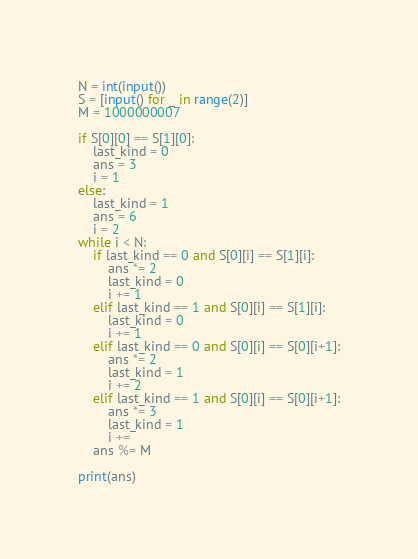Convert code to text. <code><loc_0><loc_0><loc_500><loc_500><_Python_>N = int(input())
S = [input() for _ in range(2)]
M = 1000000007

if S[0][0] == S[1][0]:
    last_kind = 0
    ans = 3
    i = 1
else:
    last_kind = 1
    ans = 6
    i = 2
while i < N:
    if last_kind == 0 and S[0][i] == S[1][i]:
        ans *= 2
        last_kind = 0
        i += 1
    elif last_kind == 1 and S[0][i] == S[1][i]:
        last_kind = 0
        i += 1
    elif last_kind == 0 and S[0][i] == S[0][i+1]:
        ans *= 2
        last_kind = 1
        i += 2
    elif last_kind == 1 and S[0][i] == S[0][i+1]:
        ans *= 3
        last_kind = 1
        i += 
    ans %= M

print(ans)
</code> 